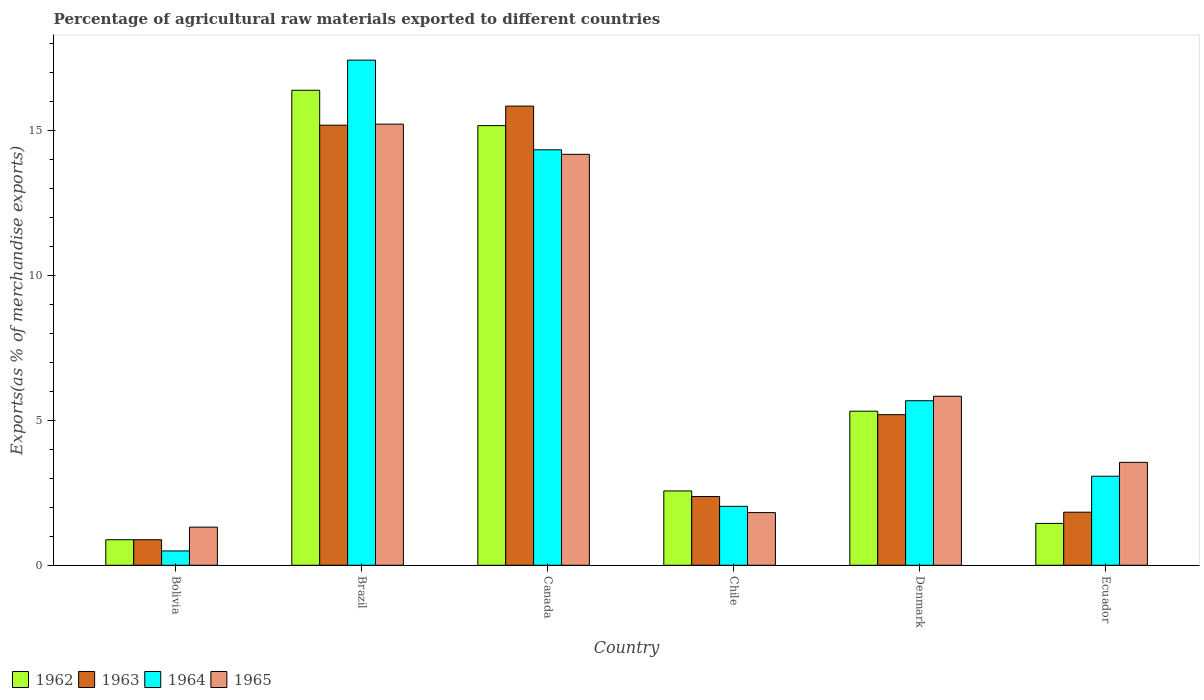How many different coloured bars are there?
Provide a short and direct response. 4. How many bars are there on the 5th tick from the left?
Keep it short and to the point. 4. What is the label of the 6th group of bars from the left?
Provide a short and direct response. Ecuador. In how many cases, is the number of bars for a given country not equal to the number of legend labels?
Your answer should be compact. 0. What is the percentage of exports to different countries in 1965 in Chile?
Give a very brief answer. 1.82. Across all countries, what is the maximum percentage of exports to different countries in 1965?
Keep it short and to the point. 15.23. Across all countries, what is the minimum percentage of exports to different countries in 1963?
Offer a terse response. 0.88. In which country was the percentage of exports to different countries in 1962 minimum?
Make the answer very short. Bolivia. What is the total percentage of exports to different countries in 1962 in the graph?
Give a very brief answer. 41.8. What is the difference between the percentage of exports to different countries in 1965 in Chile and that in Ecuador?
Provide a succinct answer. -1.73. What is the difference between the percentage of exports to different countries in 1963 in Denmark and the percentage of exports to different countries in 1965 in Chile?
Make the answer very short. 3.38. What is the average percentage of exports to different countries in 1964 per country?
Make the answer very short. 7.18. What is the difference between the percentage of exports to different countries of/in 1964 and percentage of exports to different countries of/in 1965 in Brazil?
Provide a succinct answer. 2.21. What is the ratio of the percentage of exports to different countries in 1962 in Chile to that in Ecuador?
Provide a succinct answer. 1.78. What is the difference between the highest and the second highest percentage of exports to different countries in 1964?
Your answer should be very brief. 11.76. What is the difference between the highest and the lowest percentage of exports to different countries in 1963?
Make the answer very short. 14.97. In how many countries, is the percentage of exports to different countries in 1964 greater than the average percentage of exports to different countries in 1964 taken over all countries?
Your response must be concise. 2. Is it the case that in every country, the sum of the percentage of exports to different countries in 1964 and percentage of exports to different countries in 1965 is greater than the sum of percentage of exports to different countries in 1962 and percentage of exports to different countries in 1963?
Your response must be concise. No. What does the 1st bar from the left in Bolivia represents?
Keep it short and to the point. 1962. Is it the case that in every country, the sum of the percentage of exports to different countries in 1962 and percentage of exports to different countries in 1965 is greater than the percentage of exports to different countries in 1963?
Your response must be concise. Yes. Are all the bars in the graph horizontal?
Keep it short and to the point. No. What is the difference between two consecutive major ticks on the Y-axis?
Keep it short and to the point. 5. Are the values on the major ticks of Y-axis written in scientific E-notation?
Ensure brevity in your answer.  No. Does the graph contain grids?
Your answer should be very brief. No. Where does the legend appear in the graph?
Give a very brief answer. Bottom left. How many legend labels are there?
Make the answer very short. 4. What is the title of the graph?
Keep it short and to the point. Percentage of agricultural raw materials exported to different countries. What is the label or title of the Y-axis?
Make the answer very short. Exports(as % of merchandise exports). What is the Exports(as % of merchandise exports) of 1962 in Bolivia?
Your answer should be compact. 0.88. What is the Exports(as % of merchandise exports) in 1963 in Bolivia?
Your answer should be very brief. 0.88. What is the Exports(as % of merchandise exports) of 1964 in Bolivia?
Provide a short and direct response. 0.49. What is the Exports(as % of merchandise exports) in 1965 in Bolivia?
Make the answer very short. 1.32. What is the Exports(as % of merchandise exports) of 1962 in Brazil?
Your response must be concise. 16.4. What is the Exports(as % of merchandise exports) of 1963 in Brazil?
Provide a succinct answer. 15.2. What is the Exports(as % of merchandise exports) in 1964 in Brazil?
Provide a succinct answer. 17.44. What is the Exports(as % of merchandise exports) of 1965 in Brazil?
Your answer should be compact. 15.23. What is the Exports(as % of merchandise exports) of 1962 in Canada?
Ensure brevity in your answer.  15.18. What is the Exports(as % of merchandise exports) of 1963 in Canada?
Your answer should be compact. 15.85. What is the Exports(as % of merchandise exports) of 1964 in Canada?
Offer a very short reply. 14.35. What is the Exports(as % of merchandise exports) of 1965 in Canada?
Keep it short and to the point. 14.19. What is the Exports(as % of merchandise exports) in 1962 in Chile?
Ensure brevity in your answer.  2.57. What is the Exports(as % of merchandise exports) of 1963 in Chile?
Provide a short and direct response. 2.37. What is the Exports(as % of merchandise exports) of 1964 in Chile?
Your answer should be compact. 2.03. What is the Exports(as % of merchandise exports) of 1965 in Chile?
Offer a very short reply. 1.82. What is the Exports(as % of merchandise exports) in 1962 in Denmark?
Offer a terse response. 5.32. What is the Exports(as % of merchandise exports) of 1963 in Denmark?
Provide a short and direct response. 5.2. What is the Exports(as % of merchandise exports) in 1964 in Denmark?
Offer a terse response. 5.68. What is the Exports(as % of merchandise exports) in 1965 in Denmark?
Offer a terse response. 5.84. What is the Exports(as % of merchandise exports) in 1962 in Ecuador?
Offer a very short reply. 1.45. What is the Exports(as % of merchandise exports) in 1963 in Ecuador?
Your answer should be compact. 1.83. What is the Exports(as % of merchandise exports) of 1964 in Ecuador?
Offer a terse response. 3.07. What is the Exports(as % of merchandise exports) of 1965 in Ecuador?
Ensure brevity in your answer.  3.55. Across all countries, what is the maximum Exports(as % of merchandise exports) of 1962?
Ensure brevity in your answer.  16.4. Across all countries, what is the maximum Exports(as % of merchandise exports) of 1963?
Offer a terse response. 15.85. Across all countries, what is the maximum Exports(as % of merchandise exports) of 1964?
Keep it short and to the point. 17.44. Across all countries, what is the maximum Exports(as % of merchandise exports) of 1965?
Your answer should be compact. 15.23. Across all countries, what is the minimum Exports(as % of merchandise exports) of 1962?
Offer a terse response. 0.88. Across all countries, what is the minimum Exports(as % of merchandise exports) in 1963?
Your answer should be compact. 0.88. Across all countries, what is the minimum Exports(as % of merchandise exports) of 1964?
Provide a succinct answer. 0.49. Across all countries, what is the minimum Exports(as % of merchandise exports) in 1965?
Offer a very short reply. 1.32. What is the total Exports(as % of merchandise exports) of 1962 in the graph?
Make the answer very short. 41.8. What is the total Exports(as % of merchandise exports) in 1963 in the graph?
Your answer should be compact. 41.34. What is the total Exports(as % of merchandise exports) in 1964 in the graph?
Your answer should be compact. 43.07. What is the total Exports(as % of merchandise exports) of 1965 in the graph?
Offer a very short reply. 41.95. What is the difference between the Exports(as % of merchandise exports) in 1962 in Bolivia and that in Brazil?
Give a very brief answer. -15.52. What is the difference between the Exports(as % of merchandise exports) of 1963 in Bolivia and that in Brazil?
Provide a short and direct response. -14.31. What is the difference between the Exports(as % of merchandise exports) of 1964 in Bolivia and that in Brazil?
Your answer should be compact. -16.95. What is the difference between the Exports(as % of merchandise exports) of 1965 in Bolivia and that in Brazil?
Make the answer very short. -13.92. What is the difference between the Exports(as % of merchandise exports) of 1962 in Bolivia and that in Canada?
Ensure brevity in your answer.  -14.3. What is the difference between the Exports(as % of merchandise exports) in 1963 in Bolivia and that in Canada?
Offer a terse response. -14.97. What is the difference between the Exports(as % of merchandise exports) in 1964 in Bolivia and that in Canada?
Your answer should be compact. -13.85. What is the difference between the Exports(as % of merchandise exports) of 1965 in Bolivia and that in Canada?
Your answer should be very brief. -12.87. What is the difference between the Exports(as % of merchandise exports) in 1962 in Bolivia and that in Chile?
Give a very brief answer. -1.69. What is the difference between the Exports(as % of merchandise exports) in 1963 in Bolivia and that in Chile?
Keep it short and to the point. -1.49. What is the difference between the Exports(as % of merchandise exports) of 1964 in Bolivia and that in Chile?
Your answer should be very brief. -1.54. What is the difference between the Exports(as % of merchandise exports) of 1965 in Bolivia and that in Chile?
Your response must be concise. -0.5. What is the difference between the Exports(as % of merchandise exports) of 1962 in Bolivia and that in Denmark?
Make the answer very short. -4.44. What is the difference between the Exports(as % of merchandise exports) in 1963 in Bolivia and that in Denmark?
Offer a very short reply. -4.32. What is the difference between the Exports(as % of merchandise exports) of 1964 in Bolivia and that in Denmark?
Offer a terse response. -5.19. What is the difference between the Exports(as % of merchandise exports) in 1965 in Bolivia and that in Denmark?
Give a very brief answer. -4.52. What is the difference between the Exports(as % of merchandise exports) of 1962 in Bolivia and that in Ecuador?
Make the answer very short. -0.56. What is the difference between the Exports(as % of merchandise exports) in 1963 in Bolivia and that in Ecuador?
Your answer should be compact. -0.95. What is the difference between the Exports(as % of merchandise exports) in 1964 in Bolivia and that in Ecuador?
Make the answer very short. -2.58. What is the difference between the Exports(as % of merchandise exports) in 1965 in Bolivia and that in Ecuador?
Offer a terse response. -2.24. What is the difference between the Exports(as % of merchandise exports) of 1962 in Brazil and that in Canada?
Ensure brevity in your answer.  1.22. What is the difference between the Exports(as % of merchandise exports) in 1963 in Brazil and that in Canada?
Offer a terse response. -0.66. What is the difference between the Exports(as % of merchandise exports) in 1964 in Brazil and that in Canada?
Ensure brevity in your answer.  3.1. What is the difference between the Exports(as % of merchandise exports) of 1965 in Brazil and that in Canada?
Provide a succinct answer. 1.04. What is the difference between the Exports(as % of merchandise exports) of 1962 in Brazil and that in Chile?
Keep it short and to the point. 13.84. What is the difference between the Exports(as % of merchandise exports) in 1963 in Brazil and that in Chile?
Make the answer very short. 12.82. What is the difference between the Exports(as % of merchandise exports) in 1964 in Brazil and that in Chile?
Provide a succinct answer. 15.41. What is the difference between the Exports(as % of merchandise exports) of 1965 in Brazil and that in Chile?
Provide a succinct answer. 13.41. What is the difference between the Exports(as % of merchandise exports) in 1962 in Brazil and that in Denmark?
Your answer should be compact. 11.08. What is the difference between the Exports(as % of merchandise exports) of 1963 in Brazil and that in Denmark?
Your response must be concise. 10. What is the difference between the Exports(as % of merchandise exports) of 1964 in Brazil and that in Denmark?
Your answer should be compact. 11.76. What is the difference between the Exports(as % of merchandise exports) of 1965 in Brazil and that in Denmark?
Make the answer very short. 9.4. What is the difference between the Exports(as % of merchandise exports) in 1962 in Brazil and that in Ecuador?
Offer a very short reply. 14.96. What is the difference between the Exports(as % of merchandise exports) in 1963 in Brazil and that in Ecuador?
Ensure brevity in your answer.  13.36. What is the difference between the Exports(as % of merchandise exports) of 1964 in Brazil and that in Ecuador?
Make the answer very short. 14.37. What is the difference between the Exports(as % of merchandise exports) in 1965 in Brazil and that in Ecuador?
Your answer should be compact. 11.68. What is the difference between the Exports(as % of merchandise exports) of 1962 in Canada and that in Chile?
Make the answer very short. 12.61. What is the difference between the Exports(as % of merchandise exports) in 1963 in Canada and that in Chile?
Make the answer very short. 13.48. What is the difference between the Exports(as % of merchandise exports) of 1964 in Canada and that in Chile?
Make the answer very short. 12.31. What is the difference between the Exports(as % of merchandise exports) of 1965 in Canada and that in Chile?
Your response must be concise. 12.37. What is the difference between the Exports(as % of merchandise exports) in 1962 in Canada and that in Denmark?
Your answer should be compact. 9.86. What is the difference between the Exports(as % of merchandise exports) in 1963 in Canada and that in Denmark?
Offer a very short reply. 10.65. What is the difference between the Exports(as % of merchandise exports) of 1964 in Canada and that in Denmark?
Your answer should be compact. 8.66. What is the difference between the Exports(as % of merchandise exports) in 1965 in Canada and that in Denmark?
Provide a short and direct response. 8.35. What is the difference between the Exports(as % of merchandise exports) in 1962 in Canada and that in Ecuador?
Provide a short and direct response. 13.74. What is the difference between the Exports(as % of merchandise exports) of 1963 in Canada and that in Ecuador?
Your answer should be very brief. 14.02. What is the difference between the Exports(as % of merchandise exports) in 1964 in Canada and that in Ecuador?
Offer a very short reply. 11.27. What is the difference between the Exports(as % of merchandise exports) of 1965 in Canada and that in Ecuador?
Your answer should be compact. 10.64. What is the difference between the Exports(as % of merchandise exports) in 1962 in Chile and that in Denmark?
Your response must be concise. -2.75. What is the difference between the Exports(as % of merchandise exports) in 1963 in Chile and that in Denmark?
Give a very brief answer. -2.83. What is the difference between the Exports(as % of merchandise exports) in 1964 in Chile and that in Denmark?
Offer a very short reply. -3.65. What is the difference between the Exports(as % of merchandise exports) of 1965 in Chile and that in Denmark?
Your answer should be compact. -4.02. What is the difference between the Exports(as % of merchandise exports) in 1962 in Chile and that in Ecuador?
Give a very brief answer. 1.12. What is the difference between the Exports(as % of merchandise exports) of 1963 in Chile and that in Ecuador?
Give a very brief answer. 0.54. What is the difference between the Exports(as % of merchandise exports) of 1964 in Chile and that in Ecuador?
Offer a terse response. -1.04. What is the difference between the Exports(as % of merchandise exports) of 1965 in Chile and that in Ecuador?
Ensure brevity in your answer.  -1.74. What is the difference between the Exports(as % of merchandise exports) of 1962 in Denmark and that in Ecuador?
Your answer should be compact. 3.87. What is the difference between the Exports(as % of merchandise exports) of 1963 in Denmark and that in Ecuador?
Offer a very short reply. 3.37. What is the difference between the Exports(as % of merchandise exports) in 1964 in Denmark and that in Ecuador?
Offer a terse response. 2.61. What is the difference between the Exports(as % of merchandise exports) in 1965 in Denmark and that in Ecuador?
Keep it short and to the point. 2.28. What is the difference between the Exports(as % of merchandise exports) in 1962 in Bolivia and the Exports(as % of merchandise exports) in 1963 in Brazil?
Provide a short and direct response. -14.31. What is the difference between the Exports(as % of merchandise exports) in 1962 in Bolivia and the Exports(as % of merchandise exports) in 1964 in Brazil?
Your response must be concise. -16.56. What is the difference between the Exports(as % of merchandise exports) of 1962 in Bolivia and the Exports(as % of merchandise exports) of 1965 in Brazil?
Provide a succinct answer. -14.35. What is the difference between the Exports(as % of merchandise exports) in 1963 in Bolivia and the Exports(as % of merchandise exports) in 1964 in Brazil?
Keep it short and to the point. -16.56. What is the difference between the Exports(as % of merchandise exports) in 1963 in Bolivia and the Exports(as % of merchandise exports) in 1965 in Brazil?
Give a very brief answer. -14.35. What is the difference between the Exports(as % of merchandise exports) in 1964 in Bolivia and the Exports(as % of merchandise exports) in 1965 in Brazil?
Offer a terse response. -14.74. What is the difference between the Exports(as % of merchandise exports) of 1962 in Bolivia and the Exports(as % of merchandise exports) of 1963 in Canada?
Keep it short and to the point. -14.97. What is the difference between the Exports(as % of merchandise exports) of 1962 in Bolivia and the Exports(as % of merchandise exports) of 1964 in Canada?
Your response must be concise. -13.46. What is the difference between the Exports(as % of merchandise exports) of 1962 in Bolivia and the Exports(as % of merchandise exports) of 1965 in Canada?
Your answer should be compact. -13.31. What is the difference between the Exports(as % of merchandise exports) of 1963 in Bolivia and the Exports(as % of merchandise exports) of 1964 in Canada?
Ensure brevity in your answer.  -13.46. What is the difference between the Exports(as % of merchandise exports) in 1963 in Bolivia and the Exports(as % of merchandise exports) in 1965 in Canada?
Provide a succinct answer. -13.31. What is the difference between the Exports(as % of merchandise exports) of 1964 in Bolivia and the Exports(as % of merchandise exports) of 1965 in Canada?
Keep it short and to the point. -13.7. What is the difference between the Exports(as % of merchandise exports) of 1962 in Bolivia and the Exports(as % of merchandise exports) of 1963 in Chile?
Provide a short and direct response. -1.49. What is the difference between the Exports(as % of merchandise exports) in 1962 in Bolivia and the Exports(as % of merchandise exports) in 1964 in Chile?
Provide a succinct answer. -1.15. What is the difference between the Exports(as % of merchandise exports) in 1962 in Bolivia and the Exports(as % of merchandise exports) in 1965 in Chile?
Offer a very short reply. -0.94. What is the difference between the Exports(as % of merchandise exports) of 1963 in Bolivia and the Exports(as % of merchandise exports) of 1964 in Chile?
Provide a short and direct response. -1.15. What is the difference between the Exports(as % of merchandise exports) of 1963 in Bolivia and the Exports(as % of merchandise exports) of 1965 in Chile?
Keep it short and to the point. -0.94. What is the difference between the Exports(as % of merchandise exports) in 1964 in Bolivia and the Exports(as % of merchandise exports) in 1965 in Chile?
Your answer should be very brief. -1.32. What is the difference between the Exports(as % of merchandise exports) in 1962 in Bolivia and the Exports(as % of merchandise exports) in 1963 in Denmark?
Make the answer very short. -4.32. What is the difference between the Exports(as % of merchandise exports) of 1962 in Bolivia and the Exports(as % of merchandise exports) of 1964 in Denmark?
Give a very brief answer. -4.8. What is the difference between the Exports(as % of merchandise exports) in 1962 in Bolivia and the Exports(as % of merchandise exports) in 1965 in Denmark?
Offer a terse response. -4.95. What is the difference between the Exports(as % of merchandise exports) of 1963 in Bolivia and the Exports(as % of merchandise exports) of 1964 in Denmark?
Keep it short and to the point. -4.8. What is the difference between the Exports(as % of merchandise exports) in 1963 in Bolivia and the Exports(as % of merchandise exports) in 1965 in Denmark?
Offer a very short reply. -4.95. What is the difference between the Exports(as % of merchandise exports) in 1964 in Bolivia and the Exports(as % of merchandise exports) in 1965 in Denmark?
Provide a succinct answer. -5.34. What is the difference between the Exports(as % of merchandise exports) in 1962 in Bolivia and the Exports(as % of merchandise exports) in 1963 in Ecuador?
Your answer should be very brief. -0.95. What is the difference between the Exports(as % of merchandise exports) in 1962 in Bolivia and the Exports(as % of merchandise exports) in 1964 in Ecuador?
Your answer should be very brief. -2.19. What is the difference between the Exports(as % of merchandise exports) in 1962 in Bolivia and the Exports(as % of merchandise exports) in 1965 in Ecuador?
Provide a succinct answer. -2.67. What is the difference between the Exports(as % of merchandise exports) in 1963 in Bolivia and the Exports(as % of merchandise exports) in 1964 in Ecuador?
Make the answer very short. -2.19. What is the difference between the Exports(as % of merchandise exports) in 1963 in Bolivia and the Exports(as % of merchandise exports) in 1965 in Ecuador?
Make the answer very short. -2.67. What is the difference between the Exports(as % of merchandise exports) of 1964 in Bolivia and the Exports(as % of merchandise exports) of 1965 in Ecuador?
Make the answer very short. -3.06. What is the difference between the Exports(as % of merchandise exports) in 1962 in Brazil and the Exports(as % of merchandise exports) in 1963 in Canada?
Offer a terse response. 0.55. What is the difference between the Exports(as % of merchandise exports) of 1962 in Brazil and the Exports(as % of merchandise exports) of 1964 in Canada?
Ensure brevity in your answer.  2.06. What is the difference between the Exports(as % of merchandise exports) in 1962 in Brazil and the Exports(as % of merchandise exports) in 1965 in Canada?
Provide a short and direct response. 2.21. What is the difference between the Exports(as % of merchandise exports) in 1963 in Brazil and the Exports(as % of merchandise exports) in 1964 in Canada?
Keep it short and to the point. 0.85. What is the difference between the Exports(as % of merchandise exports) of 1963 in Brazil and the Exports(as % of merchandise exports) of 1965 in Canada?
Offer a terse response. 1.01. What is the difference between the Exports(as % of merchandise exports) in 1964 in Brazil and the Exports(as % of merchandise exports) in 1965 in Canada?
Offer a very short reply. 3.25. What is the difference between the Exports(as % of merchandise exports) of 1962 in Brazil and the Exports(as % of merchandise exports) of 1963 in Chile?
Make the answer very short. 14.03. What is the difference between the Exports(as % of merchandise exports) of 1962 in Brazil and the Exports(as % of merchandise exports) of 1964 in Chile?
Make the answer very short. 14.37. What is the difference between the Exports(as % of merchandise exports) in 1962 in Brazil and the Exports(as % of merchandise exports) in 1965 in Chile?
Your answer should be very brief. 14.58. What is the difference between the Exports(as % of merchandise exports) in 1963 in Brazil and the Exports(as % of merchandise exports) in 1964 in Chile?
Give a very brief answer. 13.16. What is the difference between the Exports(as % of merchandise exports) of 1963 in Brazil and the Exports(as % of merchandise exports) of 1965 in Chile?
Offer a terse response. 13.38. What is the difference between the Exports(as % of merchandise exports) in 1964 in Brazil and the Exports(as % of merchandise exports) in 1965 in Chile?
Your answer should be compact. 15.62. What is the difference between the Exports(as % of merchandise exports) of 1962 in Brazil and the Exports(as % of merchandise exports) of 1963 in Denmark?
Your answer should be very brief. 11.2. What is the difference between the Exports(as % of merchandise exports) in 1962 in Brazil and the Exports(as % of merchandise exports) in 1964 in Denmark?
Provide a short and direct response. 10.72. What is the difference between the Exports(as % of merchandise exports) in 1962 in Brazil and the Exports(as % of merchandise exports) in 1965 in Denmark?
Give a very brief answer. 10.57. What is the difference between the Exports(as % of merchandise exports) of 1963 in Brazil and the Exports(as % of merchandise exports) of 1964 in Denmark?
Your response must be concise. 9.51. What is the difference between the Exports(as % of merchandise exports) of 1963 in Brazil and the Exports(as % of merchandise exports) of 1965 in Denmark?
Your answer should be very brief. 9.36. What is the difference between the Exports(as % of merchandise exports) of 1964 in Brazil and the Exports(as % of merchandise exports) of 1965 in Denmark?
Your answer should be very brief. 11.61. What is the difference between the Exports(as % of merchandise exports) in 1962 in Brazil and the Exports(as % of merchandise exports) in 1963 in Ecuador?
Give a very brief answer. 14.57. What is the difference between the Exports(as % of merchandise exports) of 1962 in Brazil and the Exports(as % of merchandise exports) of 1964 in Ecuador?
Give a very brief answer. 13.33. What is the difference between the Exports(as % of merchandise exports) in 1962 in Brazil and the Exports(as % of merchandise exports) in 1965 in Ecuador?
Give a very brief answer. 12.85. What is the difference between the Exports(as % of merchandise exports) in 1963 in Brazil and the Exports(as % of merchandise exports) in 1964 in Ecuador?
Offer a very short reply. 12.12. What is the difference between the Exports(as % of merchandise exports) of 1963 in Brazil and the Exports(as % of merchandise exports) of 1965 in Ecuador?
Keep it short and to the point. 11.64. What is the difference between the Exports(as % of merchandise exports) of 1964 in Brazil and the Exports(as % of merchandise exports) of 1965 in Ecuador?
Ensure brevity in your answer.  13.89. What is the difference between the Exports(as % of merchandise exports) in 1962 in Canada and the Exports(as % of merchandise exports) in 1963 in Chile?
Your answer should be compact. 12.81. What is the difference between the Exports(as % of merchandise exports) in 1962 in Canada and the Exports(as % of merchandise exports) in 1964 in Chile?
Ensure brevity in your answer.  13.15. What is the difference between the Exports(as % of merchandise exports) of 1962 in Canada and the Exports(as % of merchandise exports) of 1965 in Chile?
Keep it short and to the point. 13.36. What is the difference between the Exports(as % of merchandise exports) of 1963 in Canada and the Exports(as % of merchandise exports) of 1964 in Chile?
Make the answer very short. 13.82. What is the difference between the Exports(as % of merchandise exports) in 1963 in Canada and the Exports(as % of merchandise exports) in 1965 in Chile?
Your answer should be very brief. 14.04. What is the difference between the Exports(as % of merchandise exports) in 1964 in Canada and the Exports(as % of merchandise exports) in 1965 in Chile?
Give a very brief answer. 12.53. What is the difference between the Exports(as % of merchandise exports) in 1962 in Canada and the Exports(as % of merchandise exports) in 1963 in Denmark?
Make the answer very short. 9.98. What is the difference between the Exports(as % of merchandise exports) of 1962 in Canada and the Exports(as % of merchandise exports) of 1964 in Denmark?
Ensure brevity in your answer.  9.5. What is the difference between the Exports(as % of merchandise exports) of 1962 in Canada and the Exports(as % of merchandise exports) of 1965 in Denmark?
Ensure brevity in your answer.  9.34. What is the difference between the Exports(as % of merchandise exports) of 1963 in Canada and the Exports(as % of merchandise exports) of 1964 in Denmark?
Ensure brevity in your answer.  10.17. What is the difference between the Exports(as % of merchandise exports) of 1963 in Canada and the Exports(as % of merchandise exports) of 1965 in Denmark?
Your answer should be compact. 10.02. What is the difference between the Exports(as % of merchandise exports) of 1964 in Canada and the Exports(as % of merchandise exports) of 1965 in Denmark?
Your answer should be very brief. 8.51. What is the difference between the Exports(as % of merchandise exports) in 1962 in Canada and the Exports(as % of merchandise exports) in 1963 in Ecuador?
Ensure brevity in your answer.  13.35. What is the difference between the Exports(as % of merchandise exports) in 1962 in Canada and the Exports(as % of merchandise exports) in 1964 in Ecuador?
Your answer should be very brief. 12.11. What is the difference between the Exports(as % of merchandise exports) of 1962 in Canada and the Exports(as % of merchandise exports) of 1965 in Ecuador?
Offer a very short reply. 11.63. What is the difference between the Exports(as % of merchandise exports) in 1963 in Canada and the Exports(as % of merchandise exports) in 1964 in Ecuador?
Your response must be concise. 12.78. What is the difference between the Exports(as % of merchandise exports) in 1963 in Canada and the Exports(as % of merchandise exports) in 1965 in Ecuador?
Ensure brevity in your answer.  12.3. What is the difference between the Exports(as % of merchandise exports) of 1964 in Canada and the Exports(as % of merchandise exports) of 1965 in Ecuador?
Ensure brevity in your answer.  10.79. What is the difference between the Exports(as % of merchandise exports) in 1962 in Chile and the Exports(as % of merchandise exports) in 1963 in Denmark?
Offer a terse response. -2.63. What is the difference between the Exports(as % of merchandise exports) in 1962 in Chile and the Exports(as % of merchandise exports) in 1964 in Denmark?
Your answer should be compact. -3.11. What is the difference between the Exports(as % of merchandise exports) of 1962 in Chile and the Exports(as % of merchandise exports) of 1965 in Denmark?
Offer a very short reply. -3.27. What is the difference between the Exports(as % of merchandise exports) of 1963 in Chile and the Exports(as % of merchandise exports) of 1964 in Denmark?
Provide a short and direct response. -3.31. What is the difference between the Exports(as % of merchandise exports) in 1963 in Chile and the Exports(as % of merchandise exports) in 1965 in Denmark?
Offer a very short reply. -3.46. What is the difference between the Exports(as % of merchandise exports) of 1964 in Chile and the Exports(as % of merchandise exports) of 1965 in Denmark?
Your answer should be very brief. -3.8. What is the difference between the Exports(as % of merchandise exports) of 1962 in Chile and the Exports(as % of merchandise exports) of 1963 in Ecuador?
Provide a succinct answer. 0.73. What is the difference between the Exports(as % of merchandise exports) in 1962 in Chile and the Exports(as % of merchandise exports) in 1964 in Ecuador?
Your answer should be compact. -0.51. What is the difference between the Exports(as % of merchandise exports) of 1962 in Chile and the Exports(as % of merchandise exports) of 1965 in Ecuador?
Your answer should be compact. -0.99. What is the difference between the Exports(as % of merchandise exports) of 1963 in Chile and the Exports(as % of merchandise exports) of 1964 in Ecuador?
Your answer should be very brief. -0.7. What is the difference between the Exports(as % of merchandise exports) of 1963 in Chile and the Exports(as % of merchandise exports) of 1965 in Ecuador?
Make the answer very short. -1.18. What is the difference between the Exports(as % of merchandise exports) of 1964 in Chile and the Exports(as % of merchandise exports) of 1965 in Ecuador?
Provide a short and direct response. -1.52. What is the difference between the Exports(as % of merchandise exports) in 1962 in Denmark and the Exports(as % of merchandise exports) in 1963 in Ecuador?
Offer a terse response. 3.49. What is the difference between the Exports(as % of merchandise exports) of 1962 in Denmark and the Exports(as % of merchandise exports) of 1964 in Ecuador?
Give a very brief answer. 2.25. What is the difference between the Exports(as % of merchandise exports) in 1962 in Denmark and the Exports(as % of merchandise exports) in 1965 in Ecuador?
Your response must be concise. 1.77. What is the difference between the Exports(as % of merchandise exports) of 1963 in Denmark and the Exports(as % of merchandise exports) of 1964 in Ecuador?
Your answer should be compact. 2.13. What is the difference between the Exports(as % of merchandise exports) in 1963 in Denmark and the Exports(as % of merchandise exports) in 1965 in Ecuador?
Your answer should be very brief. 1.65. What is the difference between the Exports(as % of merchandise exports) of 1964 in Denmark and the Exports(as % of merchandise exports) of 1965 in Ecuador?
Keep it short and to the point. 2.13. What is the average Exports(as % of merchandise exports) of 1962 per country?
Provide a succinct answer. 6.97. What is the average Exports(as % of merchandise exports) in 1963 per country?
Ensure brevity in your answer.  6.89. What is the average Exports(as % of merchandise exports) of 1964 per country?
Your answer should be compact. 7.18. What is the average Exports(as % of merchandise exports) in 1965 per country?
Provide a short and direct response. 6.99. What is the difference between the Exports(as % of merchandise exports) in 1962 and Exports(as % of merchandise exports) in 1964 in Bolivia?
Your answer should be compact. 0.39. What is the difference between the Exports(as % of merchandise exports) in 1962 and Exports(as % of merchandise exports) in 1965 in Bolivia?
Offer a very short reply. -0.43. What is the difference between the Exports(as % of merchandise exports) in 1963 and Exports(as % of merchandise exports) in 1964 in Bolivia?
Provide a short and direct response. 0.39. What is the difference between the Exports(as % of merchandise exports) of 1963 and Exports(as % of merchandise exports) of 1965 in Bolivia?
Make the answer very short. -0.43. What is the difference between the Exports(as % of merchandise exports) of 1964 and Exports(as % of merchandise exports) of 1965 in Bolivia?
Your answer should be compact. -0.82. What is the difference between the Exports(as % of merchandise exports) in 1962 and Exports(as % of merchandise exports) in 1963 in Brazil?
Your answer should be very brief. 1.21. What is the difference between the Exports(as % of merchandise exports) in 1962 and Exports(as % of merchandise exports) in 1964 in Brazil?
Make the answer very short. -1.04. What is the difference between the Exports(as % of merchandise exports) in 1962 and Exports(as % of merchandise exports) in 1965 in Brazil?
Offer a very short reply. 1.17. What is the difference between the Exports(as % of merchandise exports) in 1963 and Exports(as % of merchandise exports) in 1964 in Brazil?
Offer a terse response. -2.25. What is the difference between the Exports(as % of merchandise exports) in 1963 and Exports(as % of merchandise exports) in 1965 in Brazil?
Provide a short and direct response. -0.04. What is the difference between the Exports(as % of merchandise exports) in 1964 and Exports(as % of merchandise exports) in 1965 in Brazil?
Ensure brevity in your answer.  2.21. What is the difference between the Exports(as % of merchandise exports) of 1962 and Exports(as % of merchandise exports) of 1963 in Canada?
Your response must be concise. -0.67. What is the difference between the Exports(as % of merchandise exports) of 1962 and Exports(as % of merchandise exports) of 1964 in Canada?
Ensure brevity in your answer.  0.83. What is the difference between the Exports(as % of merchandise exports) in 1963 and Exports(as % of merchandise exports) in 1964 in Canada?
Make the answer very short. 1.51. What is the difference between the Exports(as % of merchandise exports) of 1963 and Exports(as % of merchandise exports) of 1965 in Canada?
Offer a terse response. 1.67. What is the difference between the Exports(as % of merchandise exports) of 1964 and Exports(as % of merchandise exports) of 1965 in Canada?
Offer a terse response. 0.16. What is the difference between the Exports(as % of merchandise exports) of 1962 and Exports(as % of merchandise exports) of 1963 in Chile?
Provide a succinct answer. 0.19. What is the difference between the Exports(as % of merchandise exports) in 1962 and Exports(as % of merchandise exports) in 1964 in Chile?
Your response must be concise. 0.53. What is the difference between the Exports(as % of merchandise exports) of 1962 and Exports(as % of merchandise exports) of 1965 in Chile?
Ensure brevity in your answer.  0.75. What is the difference between the Exports(as % of merchandise exports) of 1963 and Exports(as % of merchandise exports) of 1964 in Chile?
Your response must be concise. 0.34. What is the difference between the Exports(as % of merchandise exports) of 1963 and Exports(as % of merchandise exports) of 1965 in Chile?
Offer a terse response. 0.55. What is the difference between the Exports(as % of merchandise exports) in 1964 and Exports(as % of merchandise exports) in 1965 in Chile?
Provide a short and direct response. 0.22. What is the difference between the Exports(as % of merchandise exports) of 1962 and Exports(as % of merchandise exports) of 1963 in Denmark?
Your answer should be very brief. 0.12. What is the difference between the Exports(as % of merchandise exports) in 1962 and Exports(as % of merchandise exports) in 1964 in Denmark?
Keep it short and to the point. -0.36. What is the difference between the Exports(as % of merchandise exports) in 1962 and Exports(as % of merchandise exports) in 1965 in Denmark?
Your answer should be very brief. -0.52. What is the difference between the Exports(as % of merchandise exports) in 1963 and Exports(as % of merchandise exports) in 1964 in Denmark?
Your answer should be compact. -0.48. What is the difference between the Exports(as % of merchandise exports) in 1963 and Exports(as % of merchandise exports) in 1965 in Denmark?
Offer a very short reply. -0.64. What is the difference between the Exports(as % of merchandise exports) of 1964 and Exports(as % of merchandise exports) of 1965 in Denmark?
Give a very brief answer. -0.15. What is the difference between the Exports(as % of merchandise exports) of 1962 and Exports(as % of merchandise exports) of 1963 in Ecuador?
Offer a very short reply. -0.39. What is the difference between the Exports(as % of merchandise exports) in 1962 and Exports(as % of merchandise exports) in 1964 in Ecuador?
Offer a terse response. -1.63. What is the difference between the Exports(as % of merchandise exports) in 1962 and Exports(as % of merchandise exports) in 1965 in Ecuador?
Make the answer very short. -2.11. What is the difference between the Exports(as % of merchandise exports) in 1963 and Exports(as % of merchandise exports) in 1964 in Ecuador?
Offer a very short reply. -1.24. What is the difference between the Exports(as % of merchandise exports) of 1963 and Exports(as % of merchandise exports) of 1965 in Ecuador?
Provide a succinct answer. -1.72. What is the difference between the Exports(as % of merchandise exports) of 1964 and Exports(as % of merchandise exports) of 1965 in Ecuador?
Ensure brevity in your answer.  -0.48. What is the ratio of the Exports(as % of merchandise exports) of 1962 in Bolivia to that in Brazil?
Your answer should be compact. 0.05. What is the ratio of the Exports(as % of merchandise exports) of 1963 in Bolivia to that in Brazil?
Your response must be concise. 0.06. What is the ratio of the Exports(as % of merchandise exports) in 1964 in Bolivia to that in Brazil?
Ensure brevity in your answer.  0.03. What is the ratio of the Exports(as % of merchandise exports) in 1965 in Bolivia to that in Brazil?
Provide a succinct answer. 0.09. What is the ratio of the Exports(as % of merchandise exports) of 1962 in Bolivia to that in Canada?
Provide a succinct answer. 0.06. What is the ratio of the Exports(as % of merchandise exports) in 1963 in Bolivia to that in Canada?
Make the answer very short. 0.06. What is the ratio of the Exports(as % of merchandise exports) in 1964 in Bolivia to that in Canada?
Give a very brief answer. 0.03. What is the ratio of the Exports(as % of merchandise exports) in 1965 in Bolivia to that in Canada?
Your response must be concise. 0.09. What is the ratio of the Exports(as % of merchandise exports) in 1962 in Bolivia to that in Chile?
Provide a succinct answer. 0.34. What is the ratio of the Exports(as % of merchandise exports) of 1963 in Bolivia to that in Chile?
Your answer should be compact. 0.37. What is the ratio of the Exports(as % of merchandise exports) in 1964 in Bolivia to that in Chile?
Your response must be concise. 0.24. What is the ratio of the Exports(as % of merchandise exports) in 1965 in Bolivia to that in Chile?
Your response must be concise. 0.72. What is the ratio of the Exports(as % of merchandise exports) in 1962 in Bolivia to that in Denmark?
Ensure brevity in your answer.  0.17. What is the ratio of the Exports(as % of merchandise exports) in 1963 in Bolivia to that in Denmark?
Make the answer very short. 0.17. What is the ratio of the Exports(as % of merchandise exports) of 1964 in Bolivia to that in Denmark?
Offer a terse response. 0.09. What is the ratio of the Exports(as % of merchandise exports) in 1965 in Bolivia to that in Denmark?
Your response must be concise. 0.23. What is the ratio of the Exports(as % of merchandise exports) of 1962 in Bolivia to that in Ecuador?
Give a very brief answer. 0.61. What is the ratio of the Exports(as % of merchandise exports) of 1963 in Bolivia to that in Ecuador?
Ensure brevity in your answer.  0.48. What is the ratio of the Exports(as % of merchandise exports) in 1964 in Bolivia to that in Ecuador?
Give a very brief answer. 0.16. What is the ratio of the Exports(as % of merchandise exports) of 1965 in Bolivia to that in Ecuador?
Provide a short and direct response. 0.37. What is the ratio of the Exports(as % of merchandise exports) of 1962 in Brazil to that in Canada?
Ensure brevity in your answer.  1.08. What is the ratio of the Exports(as % of merchandise exports) in 1963 in Brazil to that in Canada?
Provide a succinct answer. 0.96. What is the ratio of the Exports(as % of merchandise exports) in 1964 in Brazil to that in Canada?
Keep it short and to the point. 1.22. What is the ratio of the Exports(as % of merchandise exports) in 1965 in Brazil to that in Canada?
Offer a terse response. 1.07. What is the ratio of the Exports(as % of merchandise exports) of 1962 in Brazil to that in Chile?
Make the answer very short. 6.39. What is the ratio of the Exports(as % of merchandise exports) in 1963 in Brazil to that in Chile?
Keep it short and to the point. 6.4. What is the ratio of the Exports(as % of merchandise exports) of 1964 in Brazil to that in Chile?
Offer a terse response. 8.57. What is the ratio of the Exports(as % of merchandise exports) of 1965 in Brazil to that in Chile?
Offer a very short reply. 8.38. What is the ratio of the Exports(as % of merchandise exports) of 1962 in Brazil to that in Denmark?
Your answer should be very brief. 3.08. What is the ratio of the Exports(as % of merchandise exports) in 1963 in Brazil to that in Denmark?
Provide a succinct answer. 2.92. What is the ratio of the Exports(as % of merchandise exports) in 1964 in Brazil to that in Denmark?
Your response must be concise. 3.07. What is the ratio of the Exports(as % of merchandise exports) in 1965 in Brazil to that in Denmark?
Your response must be concise. 2.61. What is the ratio of the Exports(as % of merchandise exports) of 1962 in Brazil to that in Ecuador?
Provide a succinct answer. 11.35. What is the ratio of the Exports(as % of merchandise exports) in 1963 in Brazil to that in Ecuador?
Your answer should be compact. 8.29. What is the ratio of the Exports(as % of merchandise exports) in 1964 in Brazil to that in Ecuador?
Ensure brevity in your answer.  5.67. What is the ratio of the Exports(as % of merchandise exports) of 1965 in Brazil to that in Ecuador?
Your response must be concise. 4.29. What is the ratio of the Exports(as % of merchandise exports) in 1962 in Canada to that in Chile?
Offer a very short reply. 5.91. What is the ratio of the Exports(as % of merchandise exports) in 1963 in Canada to that in Chile?
Offer a terse response. 6.68. What is the ratio of the Exports(as % of merchandise exports) in 1964 in Canada to that in Chile?
Give a very brief answer. 7.05. What is the ratio of the Exports(as % of merchandise exports) of 1965 in Canada to that in Chile?
Your response must be concise. 7.8. What is the ratio of the Exports(as % of merchandise exports) of 1962 in Canada to that in Denmark?
Provide a succinct answer. 2.85. What is the ratio of the Exports(as % of merchandise exports) in 1963 in Canada to that in Denmark?
Provide a succinct answer. 3.05. What is the ratio of the Exports(as % of merchandise exports) of 1964 in Canada to that in Denmark?
Keep it short and to the point. 2.53. What is the ratio of the Exports(as % of merchandise exports) in 1965 in Canada to that in Denmark?
Your answer should be compact. 2.43. What is the ratio of the Exports(as % of merchandise exports) in 1962 in Canada to that in Ecuador?
Your answer should be very brief. 10.5. What is the ratio of the Exports(as % of merchandise exports) in 1963 in Canada to that in Ecuador?
Your answer should be very brief. 8.65. What is the ratio of the Exports(as % of merchandise exports) of 1964 in Canada to that in Ecuador?
Your answer should be very brief. 4.67. What is the ratio of the Exports(as % of merchandise exports) of 1965 in Canada to that in Ecuador?
Give a very brief answer. 3.99. What is the ratio of the Exports(as % of merchandise exports) of 1962 in Chile to that in Denmark?
Your answer should be compact. 0.48. What is the ratio of the Exports(as % of merchandise exports) in 1963 in Chile to that in Denmark?
Ensure brevity in your answer.  0.46. What is the ratio of the Exports(as % of merchandise exports) in 1964 in Chile to that in Denmark?
Make the answer very short. 0.36. What is the ratio of the Exports(as % of merchandise exports) of 1965 in Chile to that in Denmark?
Provide a succinct answer. 0.31. What is the ratio of the Exports(as % of merchandise exports) in 1962 in Chile to that in Ecuador?
Provide a short and direct response. 1.78. What is the ratio of the Exports(as % of merchandise exports) of 1963 in Chile to that in Ecuador?
Ensure brevity in your answer.  1.3. What is the ratio of the Exports(as % of merchandise exports) of 1964 in Chile to that in Ecuador?
Your response must be concise. 0.66. What is the ratio of the Exports(as % of merchandise exports) in 1965 in Chile to that in Ecuador?
Provide a succinct answer. 0.51. What is the ratio of the Exports(as % of merchandise exports) of 1962 in Denmark to that in Ecuador?
Offer a terse response. 3.68. What is the ratio of the Exports(as % of merchandise exports) in 1963 in Denmark to that in Ecuador?
Ensure brevity in your answer.  2.84. What is the ratio of the Exports(as % of merchandise exports) in 1964 in Denmark to that in Ecuador?
Your answer should be very brief. 1.85. What is the ratio of the Exports(as % of merchandise exports) of 1965 in Denmark to that in Ecuador?
Your answer should be very brief. 1.64. What is the difference between the highest and the second highest Exports(as % of merchandise exports) of 1962?
Your answer should be compact. 1.22. What is the difference between the highest and the second highest Exports(as % of merchandise exports) in 1963?
Your response must be concise. 0.66. What is the difference between the highest and the second highest Exports(as % of merchandise exports) of 1964?
Give a very brief answer. 3.1. What is the difference between the highest and the second highest Exports(as % of merchandise exports) in 1965?
Offer a very short reply. 1.04. What is the difference between the highest and the lowest Exports(as % of merchandise exports) of 1962?
Your answer should be compact. 15.52. What is the difference between the highest and the lowest Exports(as % of merchandise exports) of 1963?
Offer a very short reply. 14.97. What is the difference between the highest and the lowest Exports(as % of merchandise exports) of 1964?
Offer a terse response. 16.95. What is the difference between the highest and the lowest Exports(as % of merchandise exports) in 1965?
Make the answer very short. 13.92. 